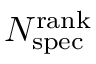Convert formula to latex. <formula><loc_0><loc_0><loc_500><loc_500>N _ { s p e c } ^ { r a n k }</formula> 